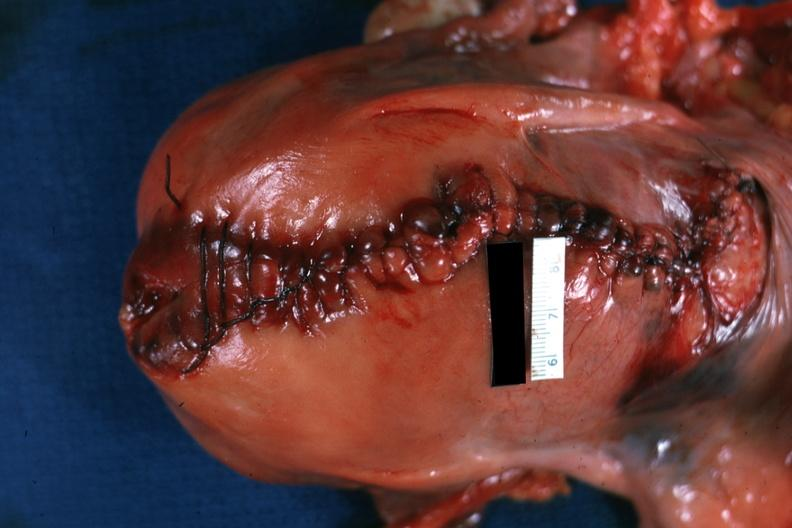what does this image show?
Answer the question using a single word or phrase. Sutured cesarean section incision 